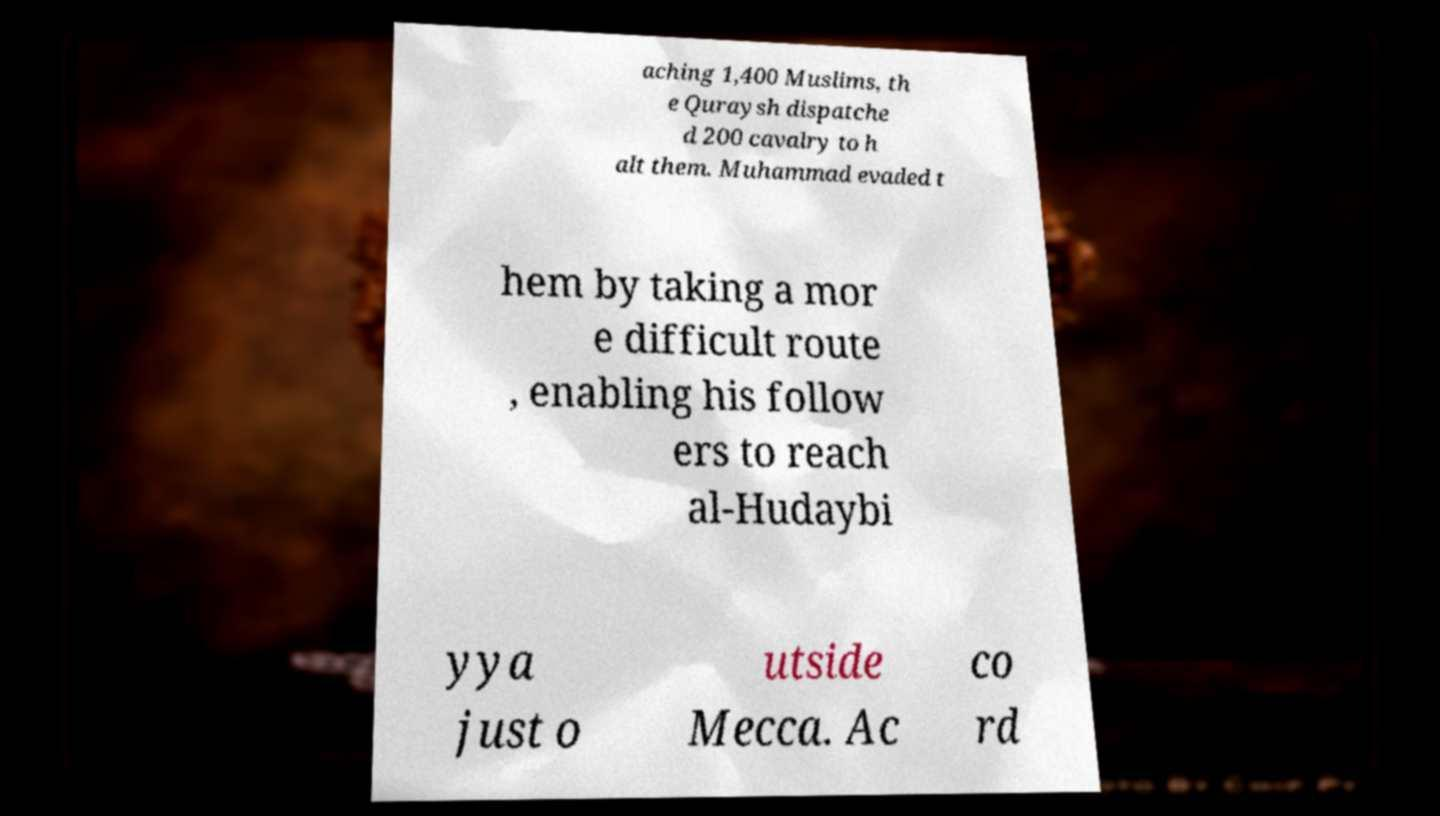There's text embedded in this image that I need extracted. Can you transcribe it verbatim? aching 1,400 Muslims, th e Quraysh dispatche d 200 cavalry to h alt them. Muhammad evaded t hem by taking a mor e difficult route , enabling his follow ers to reach al-Hudaybi yya just o utside Mecca. Ac co rd 